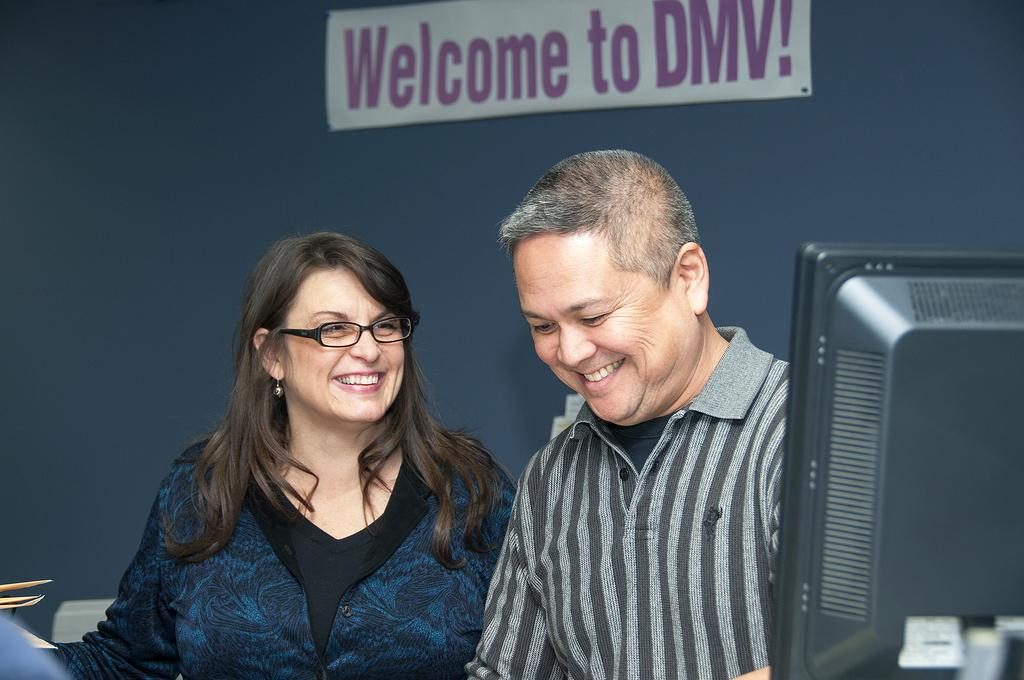Who are the people in the image? There is a man and a woman in the image. Where are the man and woman located in the image? The man and woman are in the center of the image. What can be seen at the top side of the image? There is a welcome poster at the top side of the image. What is on the right side of the image? There is a monitor on the right side of the image. What substance is being used to create a low-temperature environment in the image? There is no substance or low-temperature environment present in the image. 